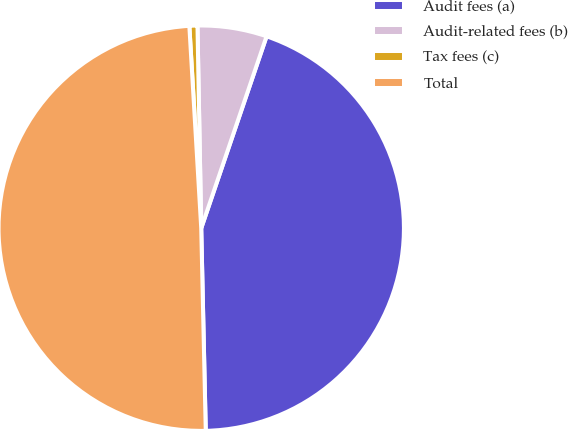<chart> <loc_0><loc_0><loc_500><loc_500><pie_chart><fcel>Audit fees (a)<fcel>Audit-related fees (b)<fcel>Tax fees (c)<fcel>Total<nl><fcel>44.42%<fcel>5.52%<fcel>0.64%<fcel>49.42%<nl></chart> 